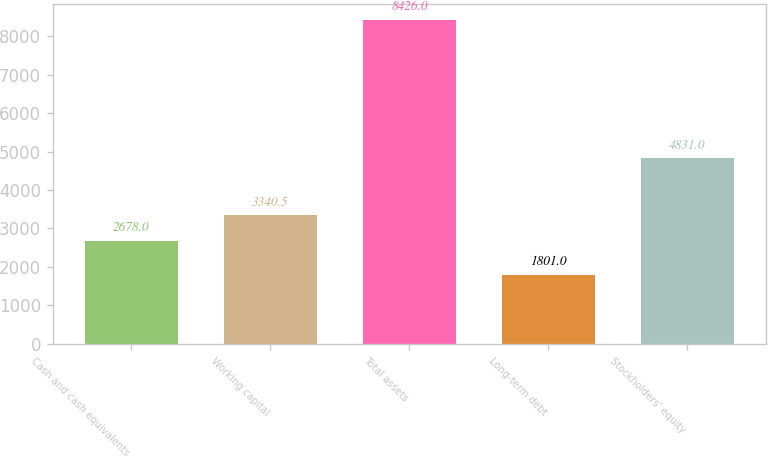Convert chart. <chart><loc_0><loc_0><loc_500><loc_500><bar_chart><fcel>Cash and cash equivalents<fcel>Working capital<fcel>Total assets<fcel>Long-term debt<fcel>Stockholders' equity<nl><fcel>2678<fcel>3340.5<fcel>8426<fcel>1801<fcel>4831<nl></chart> 